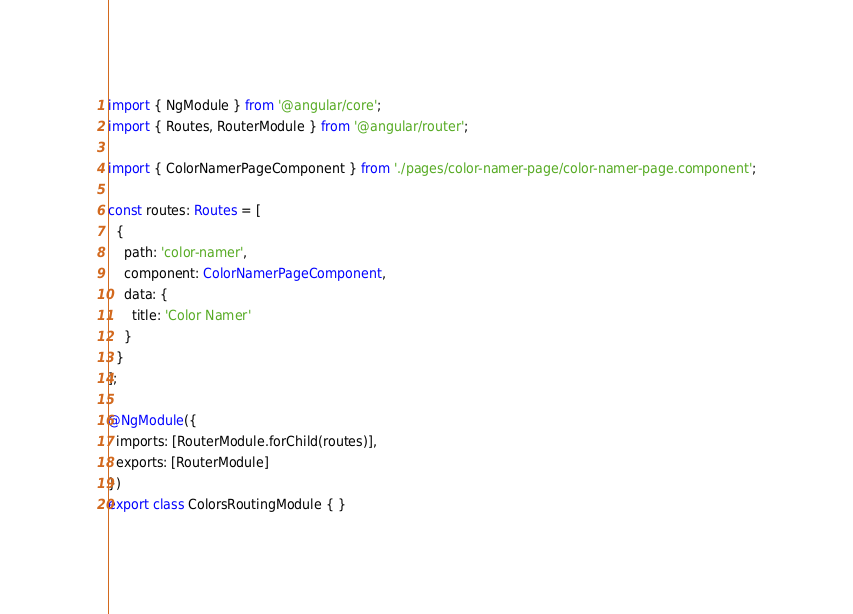Convert code to text. <code><loc_0><loc_0><loc_500><loc_500><_TypeScript_>import { NgModule } from '@angular/core';
import { Routes, RouterModule } from '@angular/router';

import { ColorNamerPageComponent } from './pages/color-namer-page/color-namer-page.component';

const routes: Routes = [
  {
    path: 'color-namer',
    component: ColorNamerPageComponent,
    data: {
      title: 'Color Namer'
    }
  }
];

@NgModule({
  imports: [RouterModule.forChild(routes)],
  exports: [RouterModule]
})
export class ColorsRoutingModule { }
</code> 